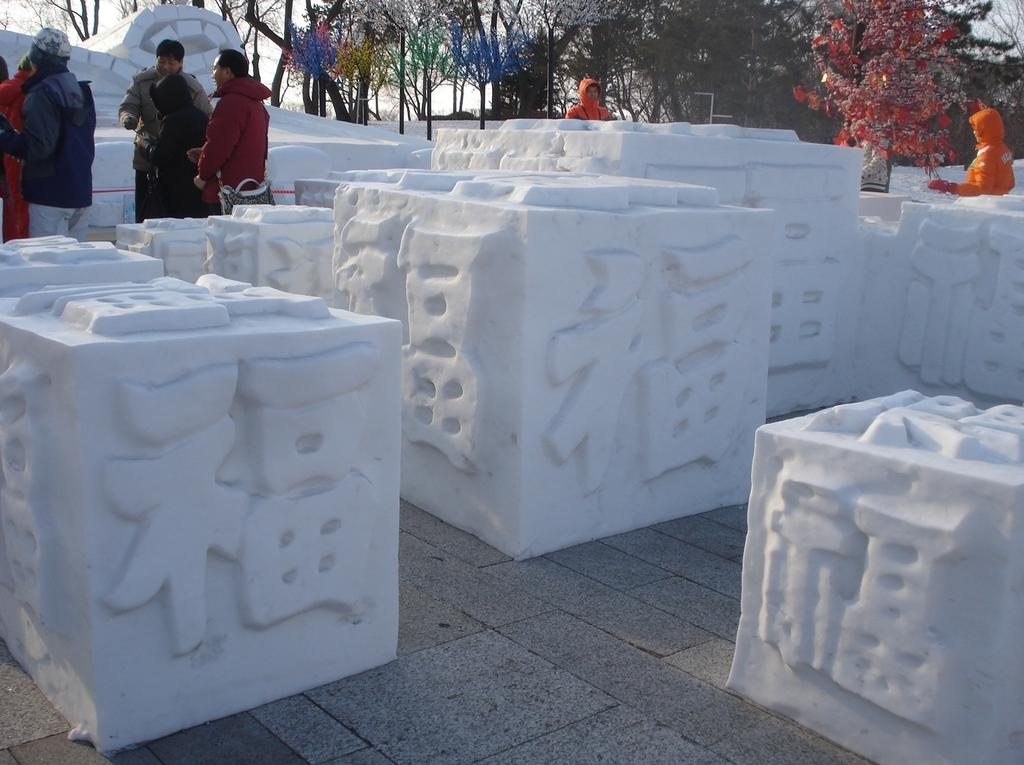What type of material is used to make the blocks in the image? The blocks in the image are made with stone. What can be seen in the background of the image? There are people standing and trees in the background of the image. Where is the door located in the image? There is no door present in the image. What type of stove is used to cook the food in the image? There is no stove present in the image. 